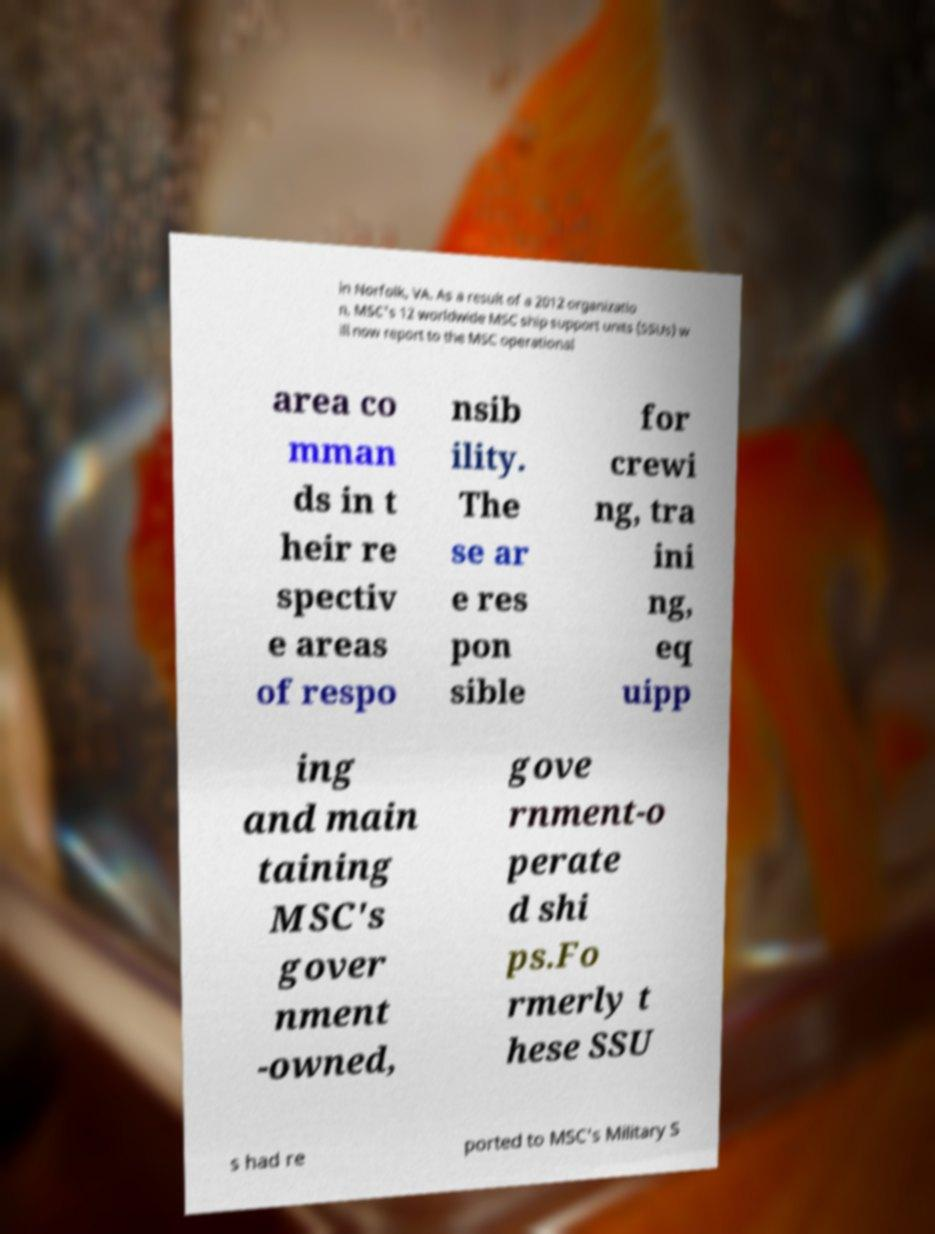There's text embedded in this image that I need extracted. Can you transcribe it verbatim? in Norfolk, VA. As a result of a 2012 organizatio n, MSC's 12 worldwide MSC ship support units (SSUs) w ill now report to the MSC operational area co mman ds in t heir re spectiv e areas of respo nsib ility. The se ar e res pon sible for crewi ng, tra ini ng, eq uipp ing and main taining MSC's gover nment -owned, gove rnment-o perate d shi ps.Fo rmerly t hese SSU s had re ported to MSC's Military S 